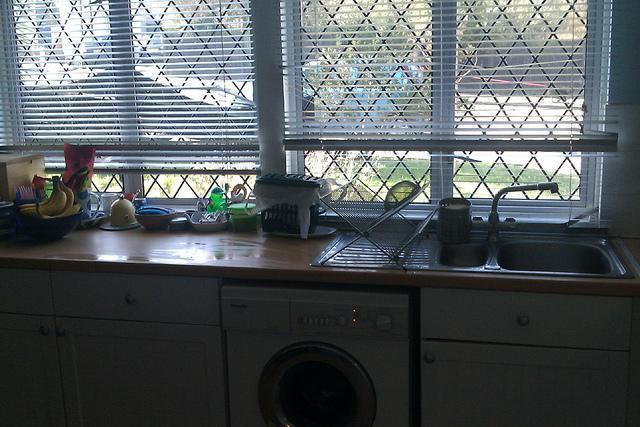How many woman are holding a donut with one hand?
Give a very brief answer. 0. 